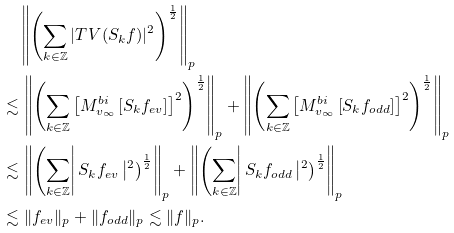Convert formula to latex. <formula><loc_0><loc_0><loc_500><loc_500>& \quad \left \| \left ( \sum _ { k \in \mathbb { Z } } | T _ { \ } V ( S _ { k } f ) | ^ { 2 } \right ) ^ { \frac { 1 } { 2 } } \right \| _ { p } \\ & \lesssim \left \| \left ( \sum _ { k \in \mathbb { Z } } \left [ M ^ { b i } _ { v _ { \infty } } \left [ S _ { k } f _ { e v } \right ] \right ] ^ { 2 } \right ) ^ { \frac { 1 } { 2 } } \right \| _ { p } + \left \| \left ( \sum _ { k \in \mathbb { Z } } \left [ M ^ { b i } _ { v _ { \infty } } \left [ S _ { k } f _ { o d d } \right ] \right ] ^ { 2 } \right ) ^ { \frac { 1 } { 2 } } \right \| _ { p } \\ & \lesssim \left \| \left ( \sum _ { k \in \mathbb { Z } } \right | S _ { k } f _ { e v } \left | ^ { 2 } \right ) ^ { \frac { 1 } { 2 } } \right \| _ { p } + \left \| \left ( \sum _ { k \in \mathbb { Z } } \right | S _ { k } f _ { o d d } \left | ^ { 2 } \right ) ^ { \frac { 1 } { 2 } } \right \| _ { p } \\ & \lesssim \| f _ { e v } \| _ { p } + \| f _ { o d d } \| _ { p } \lesssim \| f \| _ { p } .</formula> 